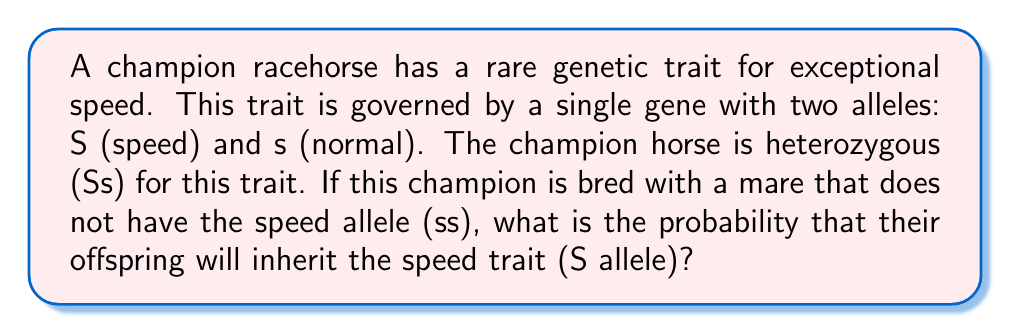Solve this math problem. To solve this problem, we need to use the principles of Mendelian genetics and probability theory. Let's break it down step-by-step:

1. Genotypes of parents:
   - Champion horse: Ss (heterozygous for speed trait)
   - Mare: ss (homozygous recessive, no speed trait)

2. Possible gametes:
   - Champion horse can produce: S or s (with equal probability)
   - Mare can only produce: s

3. Punnett square for this cross:

   $$
   \begin{array}{c|c|c}
    & \text{S} & \text{s} \\
   \hline
   \text{s} & \text{Ss} & \text{ss} \\
   \end{array}
   $$

4. Possible offspring genotypes and their probabilities:
   - Ss: 1/2 (50%)
   - ss: 1/2 (50%)

5. The speed trait (S allele) is present in the Ss genotype.

6. Therefore, the probability of the offspring inheriting the speed trait is equal to the probability of getting the Ss genotype, which is 1/2 or 50%.

This can be expressed mathematically as:

$$P(\text{offspring inherits S allele}) = P(\text{Ss genotype}) = \frac{1}{2} = 0.5$$
Answer: The probability that the offspring will inherit the speed trait (S allele) is $\frac{1}{2}$ or 0.5 (50%). 